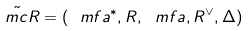Convert formula to latex. <formula><loc_0><loc_0><loc_500><loc_500>\tilde { \ m c R } = ( \ m f a ^ { * } , R , \ m f a , R ^ { \vee } , \Delta )</formula> 